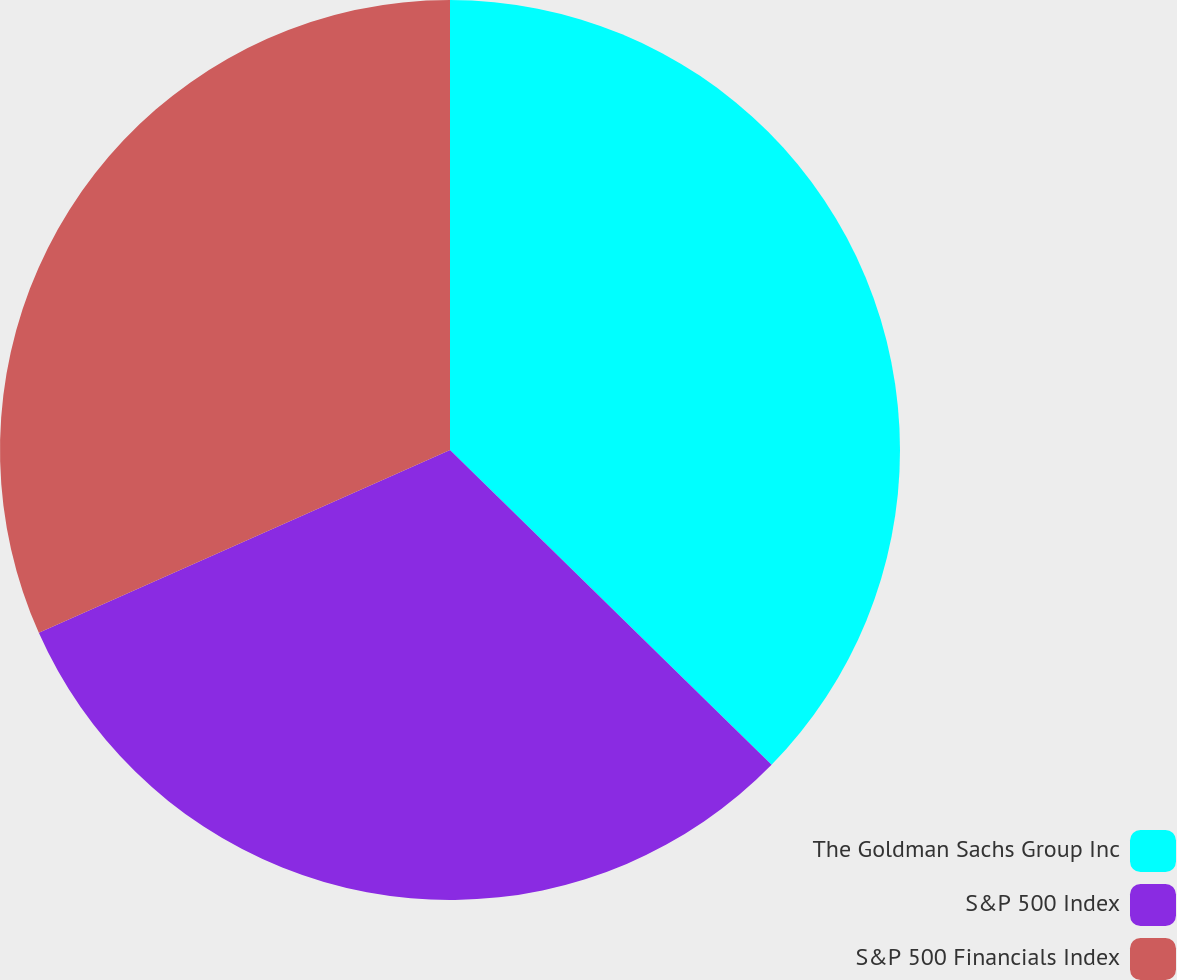<chart> <loc_0><loc_0><loc_500><loc_500><pie_chart><fcel>The Goldman Sachs Group Inc<fcel>S&P 500 Index<fcel>S&P 500 Financials Index<nl><fcel>37.33%<fcel>31.01%<fcel>31.66%<nl></chart> 